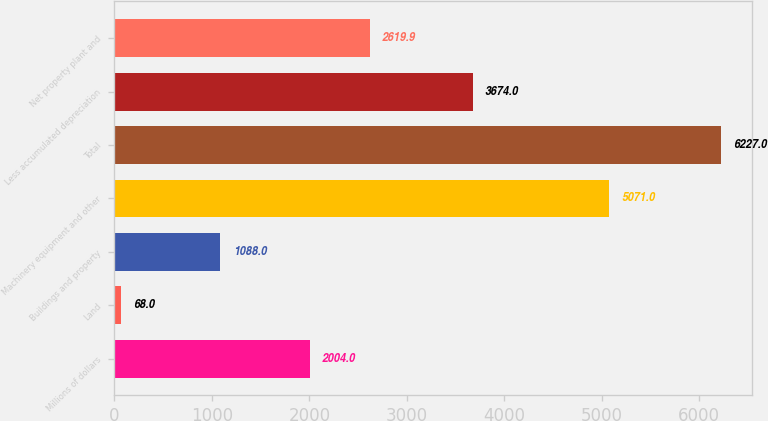Convert chart to OTSL. <chart><loc_0><loc_0><loc_500><loc_500><bar_chart><fcel>Millions of dollars<fcel>Land<fcel>Buildings and property<fcel>Machinery equipment and other<fcel>Total<fcel>Less accumulated depreciation<fcel>Net property plant and<nl><fcel>2004<fcel>68<fcel>1088<fcel>5071<fcel>6227<fcel>3674<fcel>2619.9<nl></chart> 